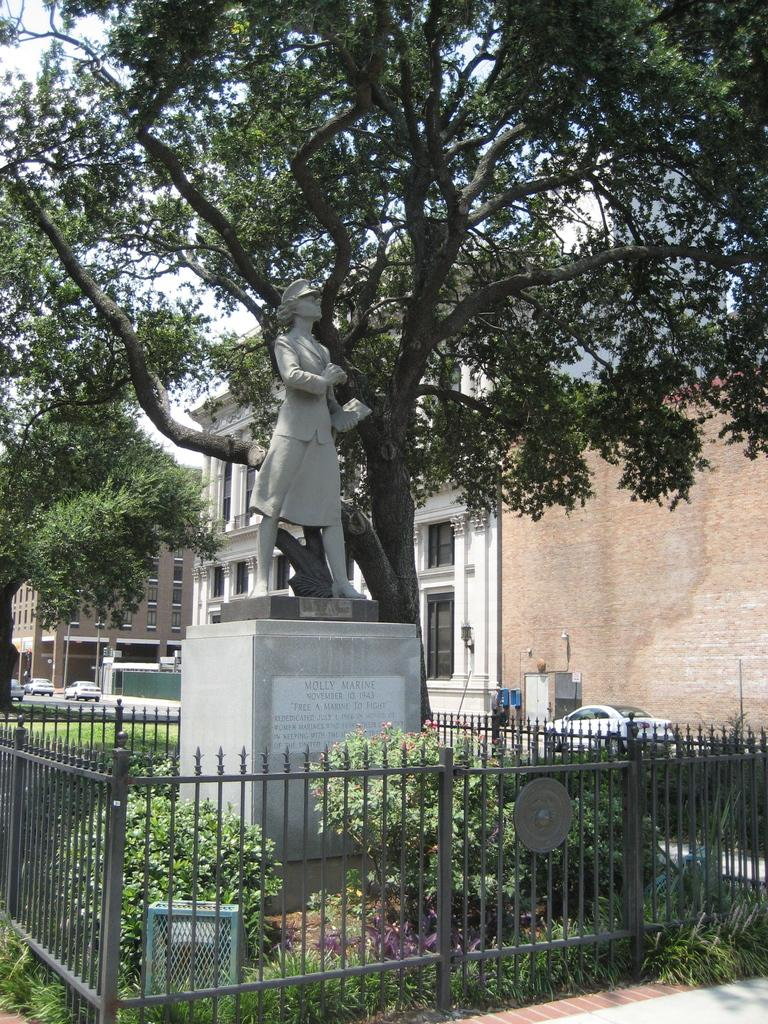<image>
Write a terse but informative summary of the picture. Statue in a gate area with the words Molly Marine inscribed on the first line. 